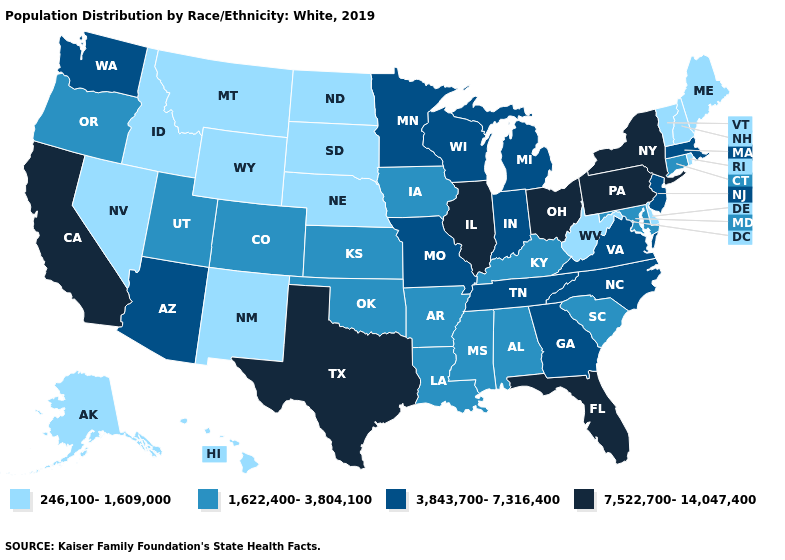What is the highest value in the USA?
Be succinct. 7,522,700-14,047,400. Which states have the lowest value in the Northeast?
Answer briefly. Maine, New Hampshire, Rhode Island, Vermont. Does Hawaii have the lowest value in the USA?
Concise answer only. Yes. Name the states that have a value in the range 7,522,700-14,047,400?
Be succinct. California, Florida, Illinois, New York, Ohio, Pennsylvania, Texas. Does South Carolina have a higher value than Indiana?
Give a very brief answer. No. Name the states that have a value in the range 3,843,700-7,316,400?
Answer briefly. Arizona, Georgia, Indiana, Massachusetts, Michigan, Minnesota, Missouri, New Jersey, North Carolina, Tennessee, Virginia, Washington, Wisconsin. What is the highest value in the South ?
Answer briefly. 7,522,700-14,047,400. Name the states that have a value in the range 7,522,700-14,047,400?
Give a very brief answer. California, Florida, Illinois, New York, Ohio, Pennsylvania, Texas. Does California have the highest value in the West?
Write a very short answer. Yes. Does the map have missing data?
Give a very brief answer. No. What is the value of North Carolina?
Be succinct. 3,843,700-7,316,400. What is the lowest value in the West?
Concise answer only. 246,100-1,609,000. Does Oregon have a higher value than Wisconsin?
Give a very brief answer. No. What is the lowest value in states that border Michigan?
Be succinct. 3,843,700-7,316,400. Does Colorado have the highest value in the USA?
Answer briefly. No. 